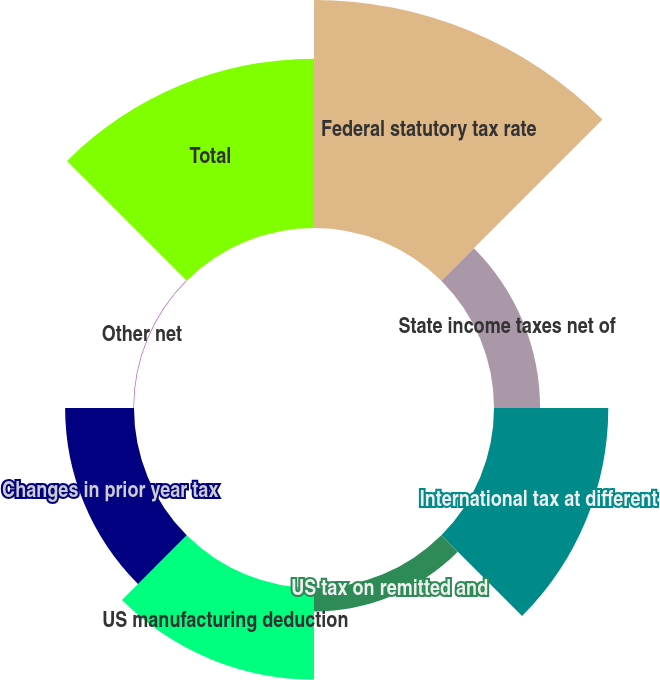<chart> <loc_0><loc_0><loc_500><loc_500><pie_chart><fcel>Federal statutory tax rate<fcel>State income taxes net of<fcel>International tax at different<fcel>US tax on remitted and<fcel>US manufacturing deduction<fcel>Changes in prior year tax<fcel>Other net<fcel>Total<nl><fcel>30.72%<fcel>6.21%<fcel>15.4%<fcel>3.15%<fcel>12.34%<fcel>9.28%<fcel>0.09%<fcel>22.82%<nl></chart> 